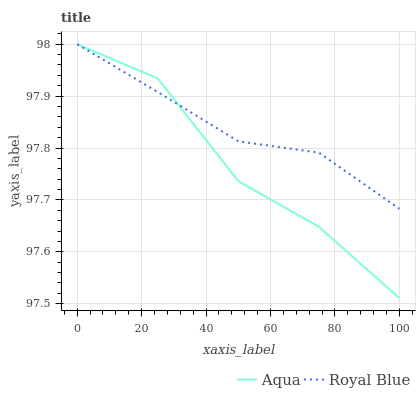Does Aqua have the minimum area under the curve?
Answer yes or no. Yes. Does Royal Blue have the maximum area under the curve?
Answer yes or no. Yes. Does Aqua have the maximum area under the curve?
Answer yes or no. No. Is Royal Blue the smoothest?
Answer yes or no. Yes. Is Aqua the roughest?
Answer yes or no. Yes. Is Aqua the smoothest?
Answer yes or no. No. 